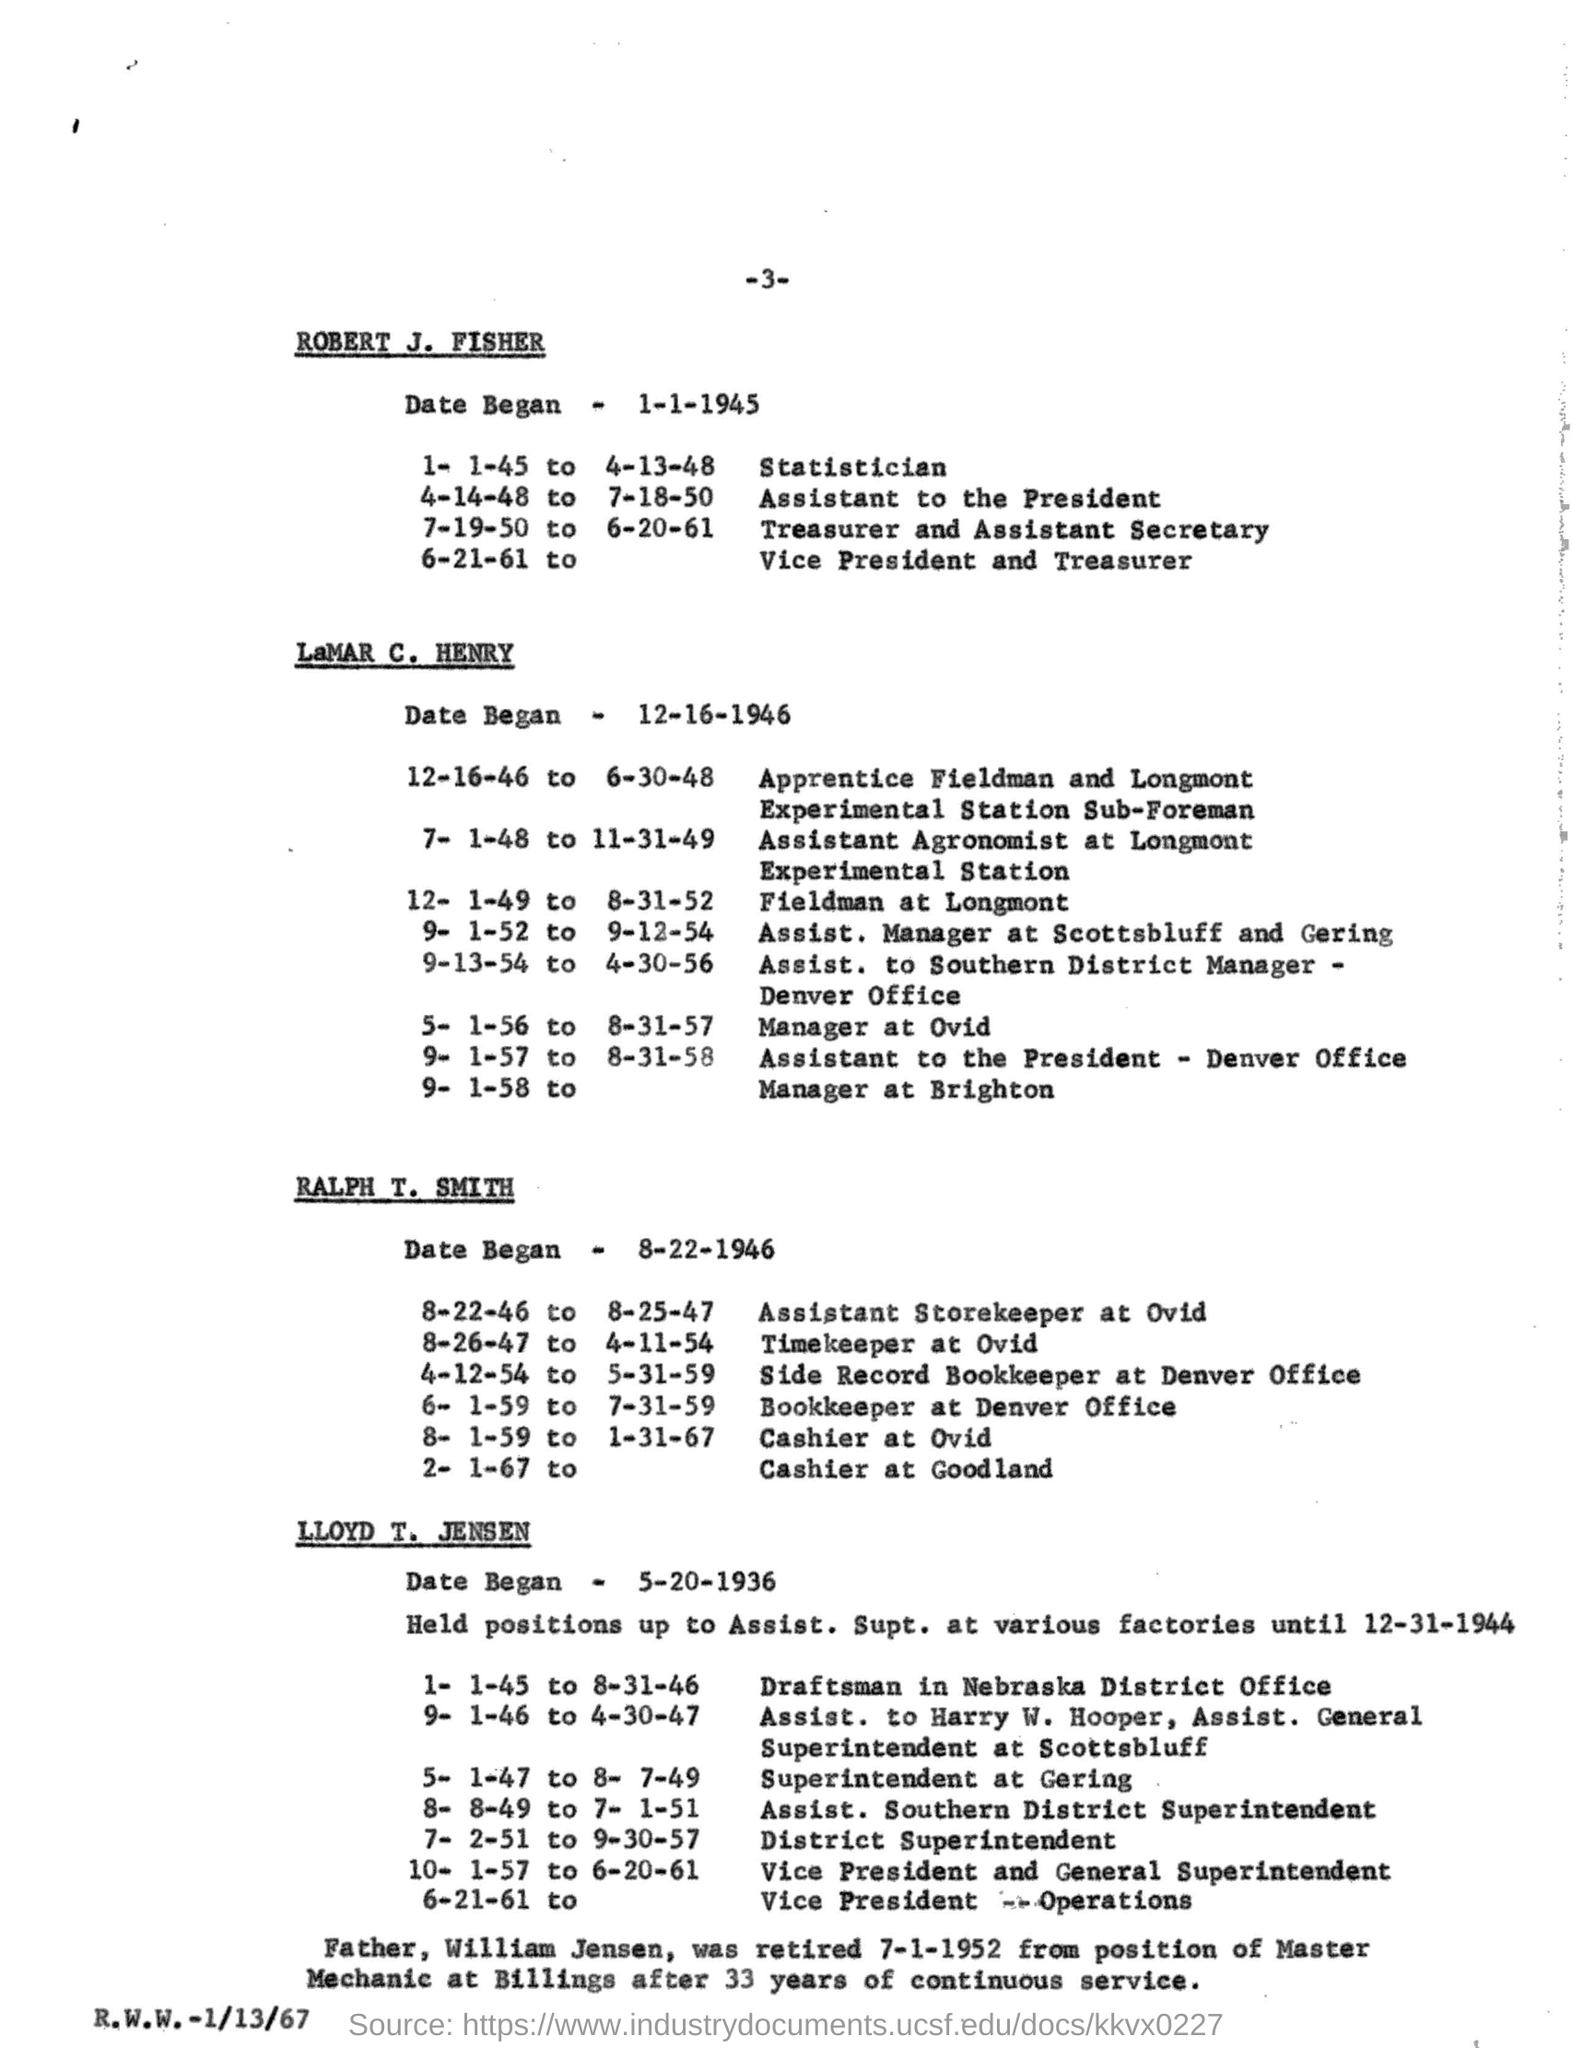Indicate a few pertinent items in this graphic. The date began on January 1, 1945, according to Robert J. Fisher. The page number of the document is 3. 